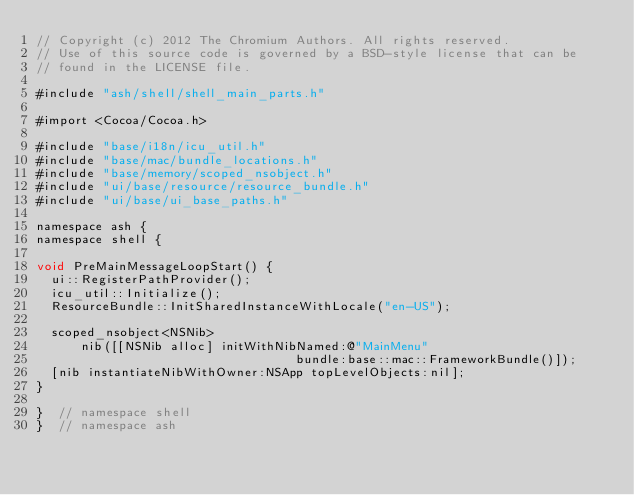<code> <loc_0><loc_0><loc_500><loc_500><_ObjectiveC_>// Copyright (c) 2012 The Chromium Authors. All rights reserved.
// Use of this source code is governed by a BSD-style license that can be
// found in the LICENSE file.

#include "ash/shell/shell_main_parts.h"

#import <Cocoa/Cocoa.h>

#include "base/i18n/icu_util.h"
#include "base/mac/bundle_locations.h"
#include "base/memory/scoped_nsobject.h"
#include "ui/base/resource/resource_bundle.h"
#include "ui/base/ui_base_paths.h"

namespace ash {
namespace shell {

void PreMainMessageLoopStart() {
  ui::RegisterPathProvider();
  icu_util::Initialize();
  ResourceBundle::InitSharedInstanceWithLocale("en-US");

  scoped_nsobject<NSNib>
      nib([[NSNib alloc] initWithNibNamed:@"MainMenu"
                                   bundle:base::mac::FrameworkBundle()]);
  [nib instantiateNibWithOwner:NSApp topLevelObjects:nil];
}

}  // namespace shell
}  // namespace ash
</code> 